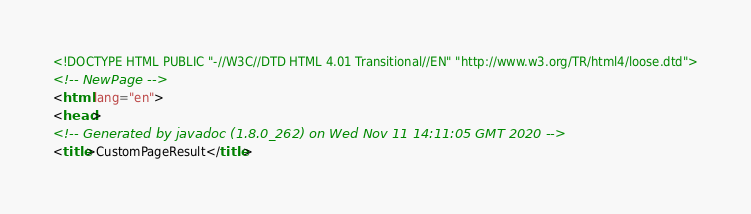<code> <loc_0><loc_0><loc_500><loc_500><_HTML_><!DOCTYPE HTML PUBLIC "-//W3C//DTD HTML 4.01 Transitional//EN" "http://www.w3.org/TR/html4/loose.dtd">
<!-- NewPage -->
<html lang="en">
<head>
<!-- Generated by javadoc (1.8.0_262) on Wed Nov 11 14:11:05 GMT 2020 -->
<title>CustomPageResult</title></code> 